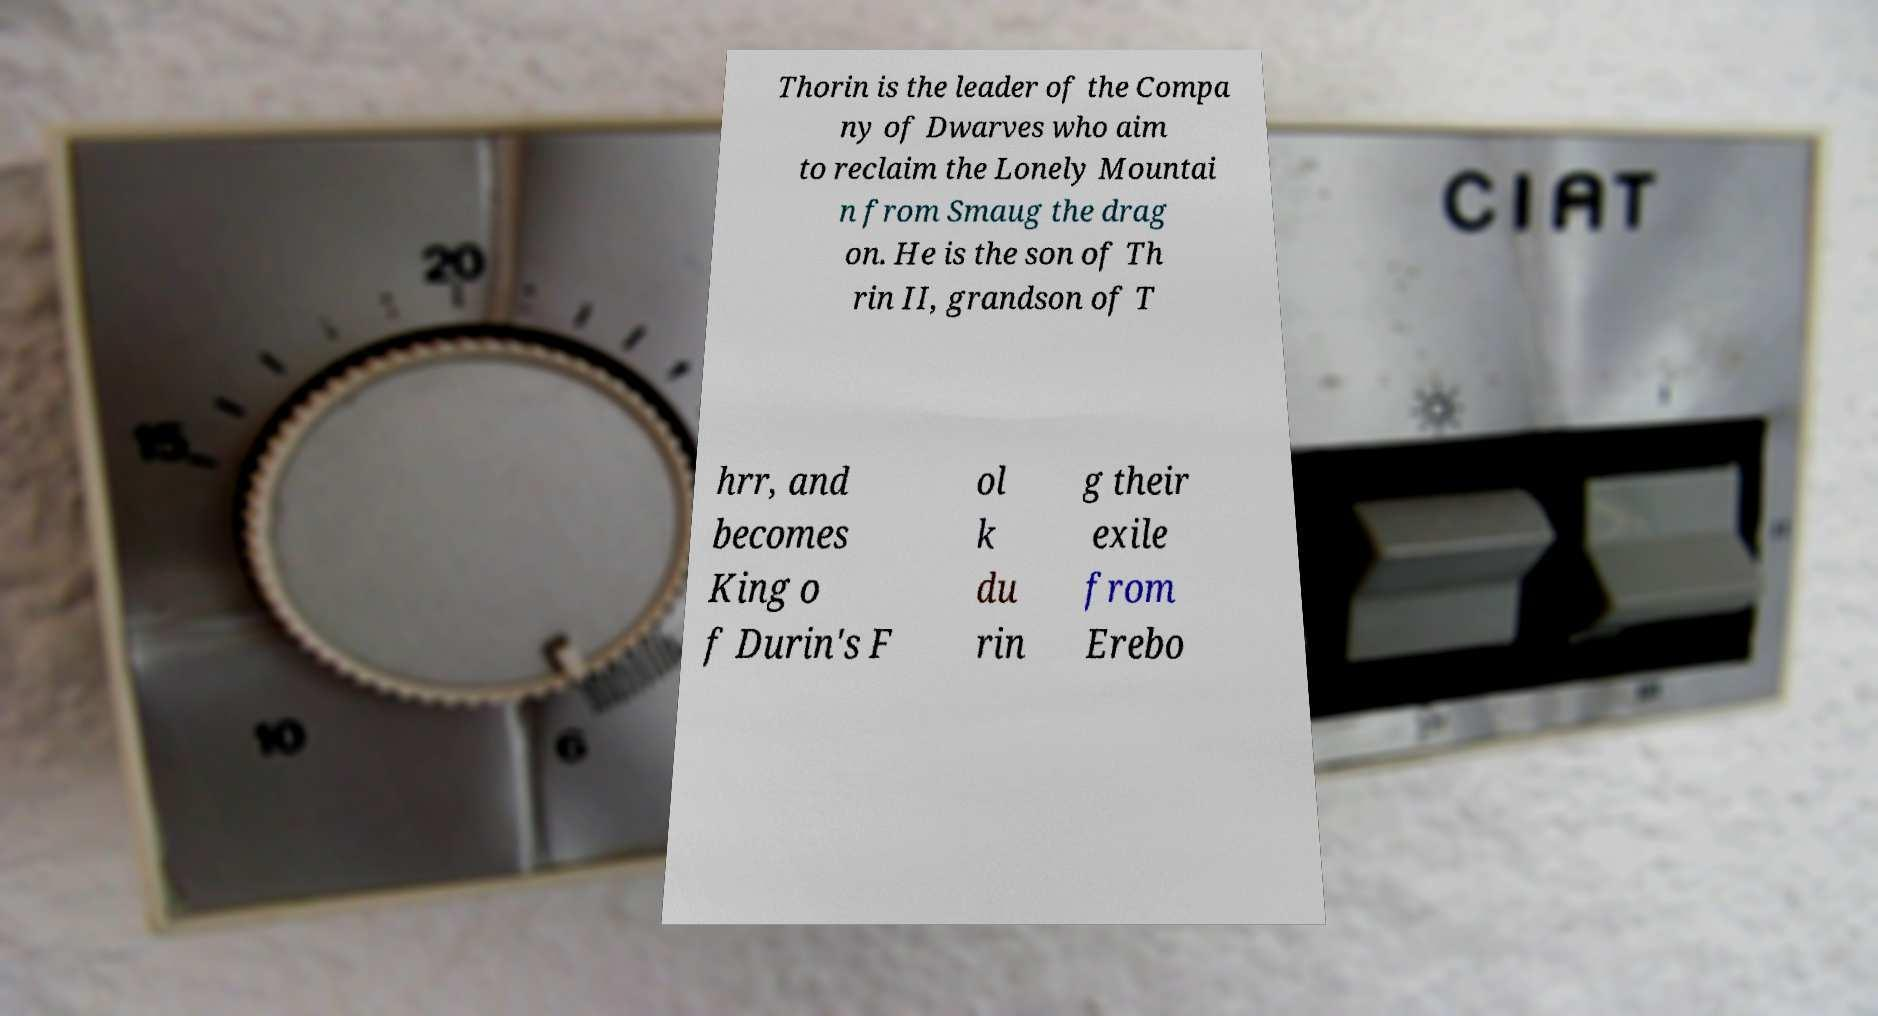Can you accurately transcribe the text from the provided image for me? Thorin is the leader of the Compa ny of Dwarves who aim to reclaim the Lonely Mountai n from Smaug the drag on. He is the son of Th rin II, grandson of T hrr, and becomes King o f Durin's F ol k du rin g their exile from Erebo 